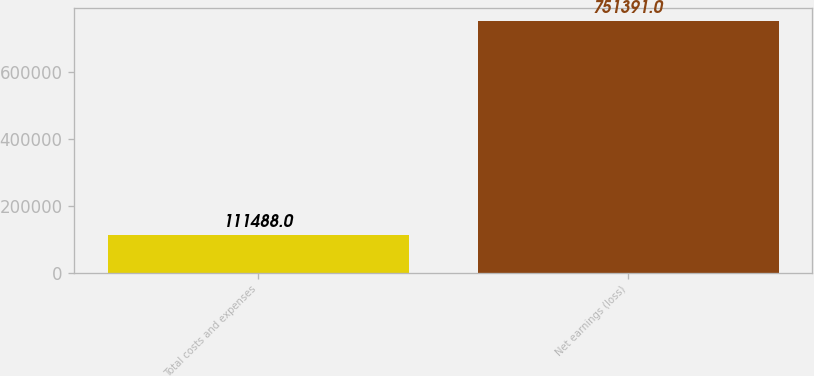<chart> <loc_0><loc_0><loc_500><loc_500><bar_chart><fcel>Total costs and expenses<fcel>Net earnings (loss)<nl><fcel>111488<fcel>751391<nl></chart> 